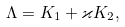Convert formula to latex. <formula><loc_0><loc_0><loc_500><loc_500>\Lambda = K _ { 1 } + \varkappa K _ { 2 } ,</formula> 